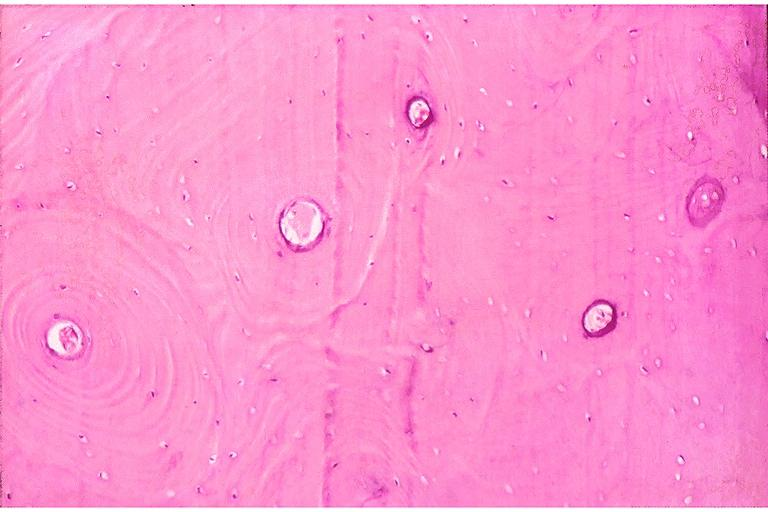s opened larynx present?
Answer the question using a single word or phrase. No 